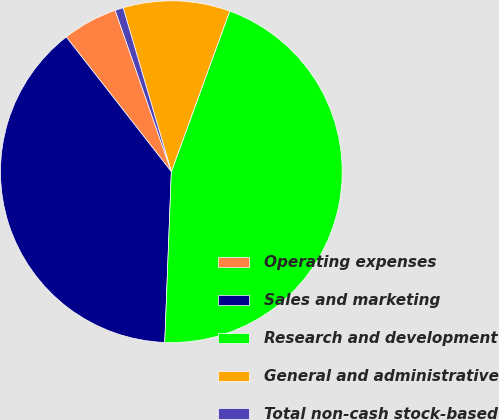<chart> <loc_0><loc_0><loc_500><loc_500><pie_chart><fcel>Operating expenses<fcel>Sales and marketing<fcel>Research and development<fcel>General and administrative<fcel>Total non-cash stock-based<nl><fcel>5.21%<fcel>38.85%<fcel>45.07%<fcel>10.1%<fcel>0.78%<nl></chart> 